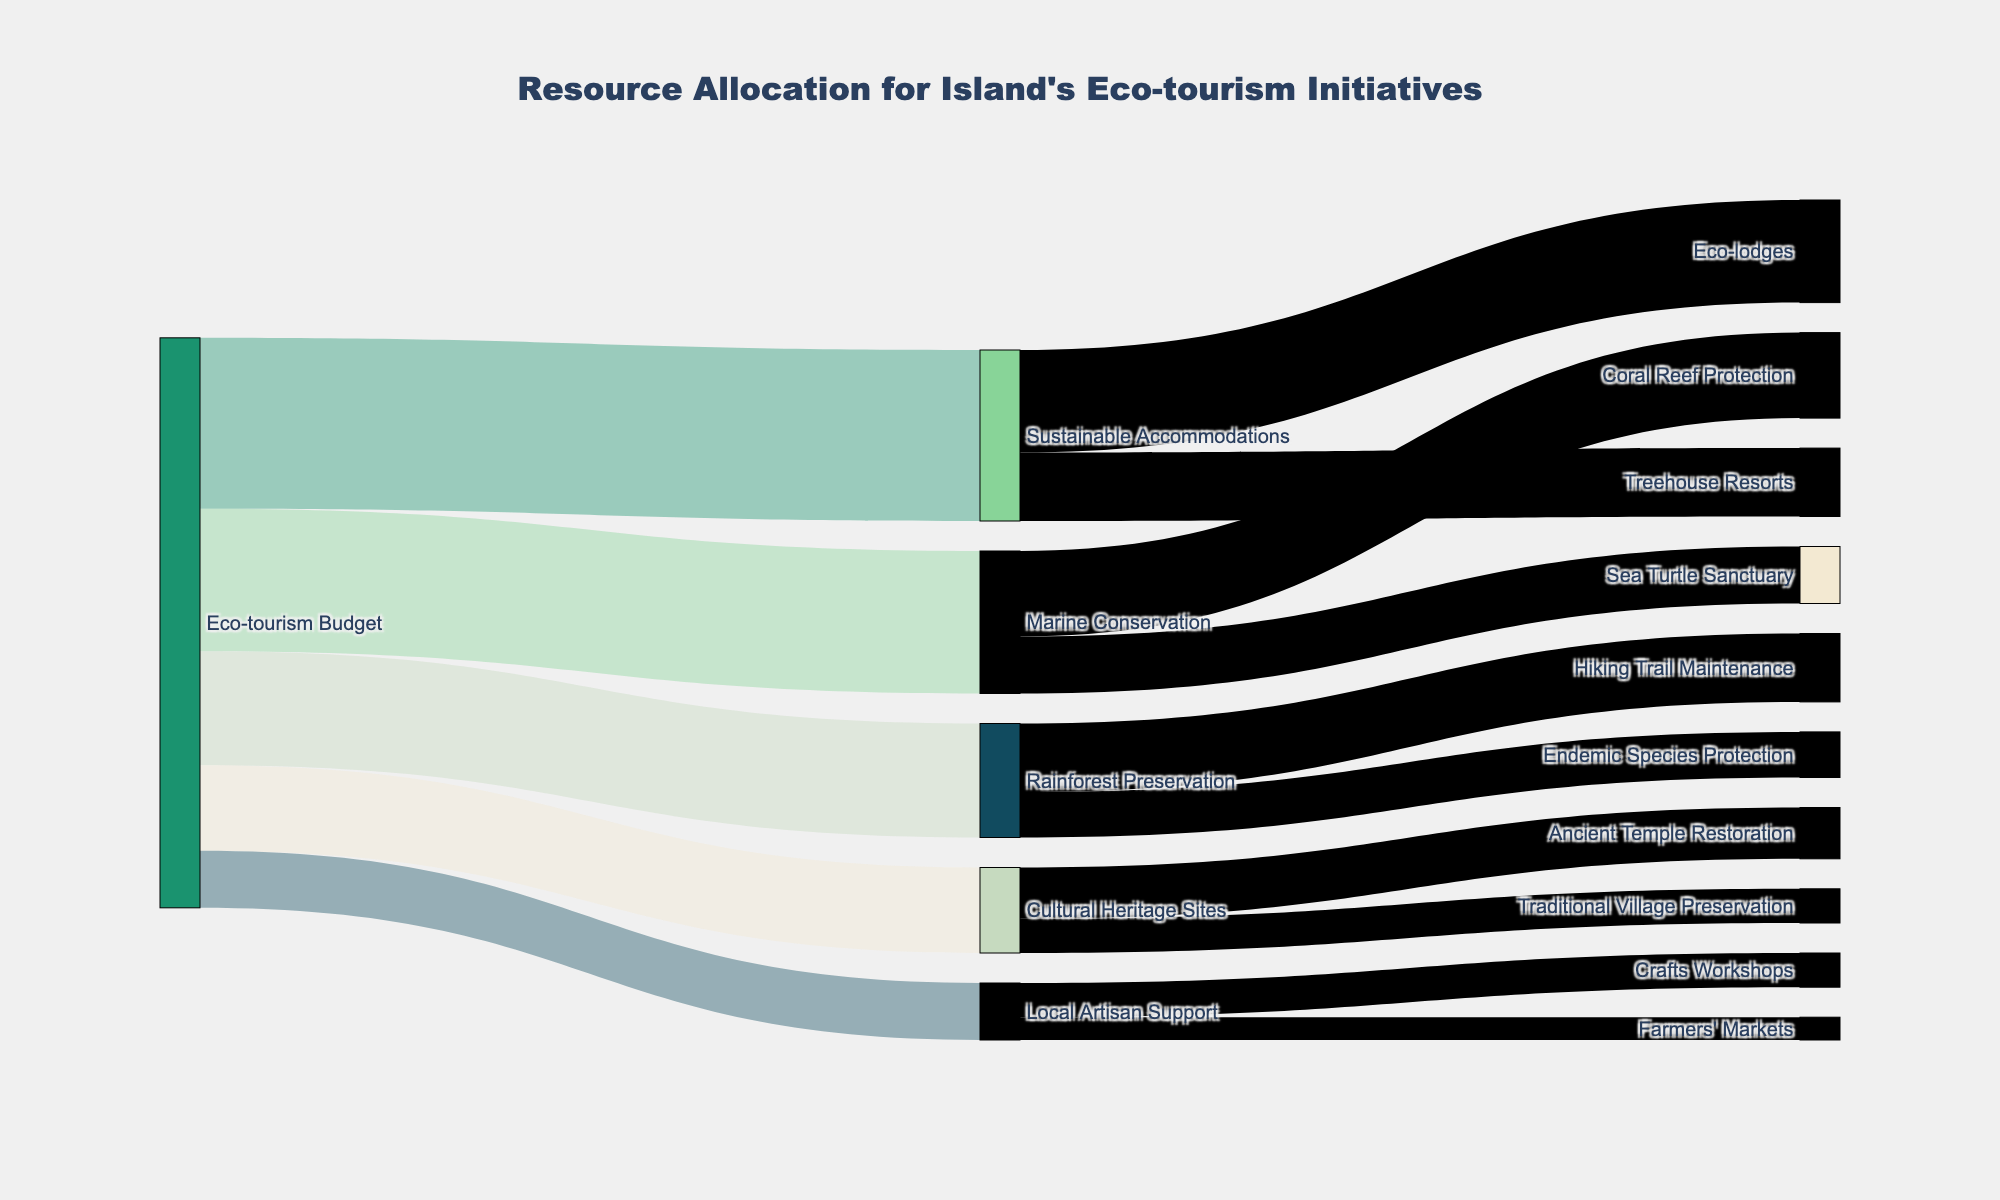how much of the eco-tourism budget is allocated to marine conservation? Look at the flow from "Eco-tourism Budget" to "Marine Conservation," which is labeled with the value
Answer: 250,000 Which sector receives the least funding from the eco-tourism budget? Compare the values of the flows from "Eco-tourism Budget" to different sectors. The smallest value is directed towards "Local Artisan Support."
Answer: Local Artisan Support How much more funding does sustainable accommodations receive compared to cultural heritage sites? Calculate the difference between the values: Sustainable Accommodations receives 300,000 and Cultural Heritage Sites receives 150,000. 300,000 - 150,000 = 150,000
Answer: 150,000 What is the total funding allocated to rainforest preservation? Sum the values of the flows from "Rainforest Preservation" to its targets: Hiking Trail Maintenance (120,000) and Endemic Species Protection (80,000). 120,000 + 80,000 = 200,000
Answer: 200,000 Which specific project within marine conservation receives the higher funding allocation? Compare the values of the flows within the "Marine Conservation" sector: Coral Reef Protection receives 150,000, and Sea Turtle Sanctuary receives 100,000. 150,000 > 100,000
Answer: Coral Reef Protection What proportion of the eco-tourism budget is allocated to cultural heritage sites? Divide the value for "Cultural Heritage Sites" (150,000) by the total eco-tourism budget, which is the sum of all sectors: 300,000 + 250,000 + 200,000 + 150,000 + 100,000 = 1,000,000. 150,000 / 1,000,000 = 0.15 or 15%
Answer: 15% How much funding is dedicated to supporting local artisans? Look at the flow from "Eco-tourism Budget" to "Local Artisan Support," which is labeled with the value
Answer: 100,000 Which project under sustainable accommodations receives more funding? Compare the values of the flows within the "Sustainable Accommodations" sector: Eco-lodges receives 180,000, and Treehouse Resorts receives 120,000. 180,000 > 120,000
Answer: Eco-lodges How does the funding for rainforest preservation compare to marine conservation? Compare the values allocated to both sectors: Rainforest Preservation receives 200,000 and Marine Conservation receives 250,000. 250,000 > 200,000
Answer: Marine Conservation receives more Total funding allocated to specific projects under cultural heritage sites? Sum the values of the flows from "Cultural Heritage Sites" to its projects: Ancient Temple Restoration (90,000) and Traditional Village Preservation (60,000). 90,000 + 60,000 = 150,000
Answer: 150,000 